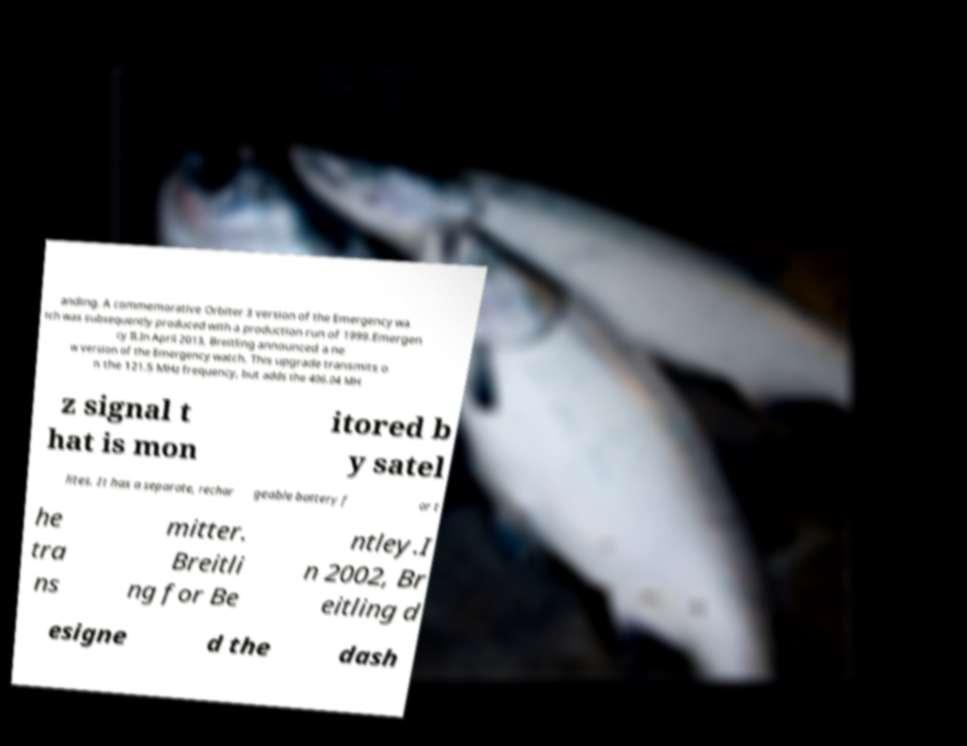Can you read and provide the text displayed in the image?This photo seems to have some interesting text. Can you extract and type it out for me? anding. A commemorative Orbiter 3 version of the Emergency wa tch was subsequently produced with a production run of 1999.Emergen cy II.In April 2013, Breitling announced a ne w version of the Emergency watch. This upgrade transmits o n the 121.5 MHz frequency, but adds the 406.04 MH z signal t hat is mon itored b y satel lites. It has a separate, rechar geable battery f or t he tra ns mitter. Breitli ng for Be ntley.I n 2002, Br eitling d esigne d the dash 